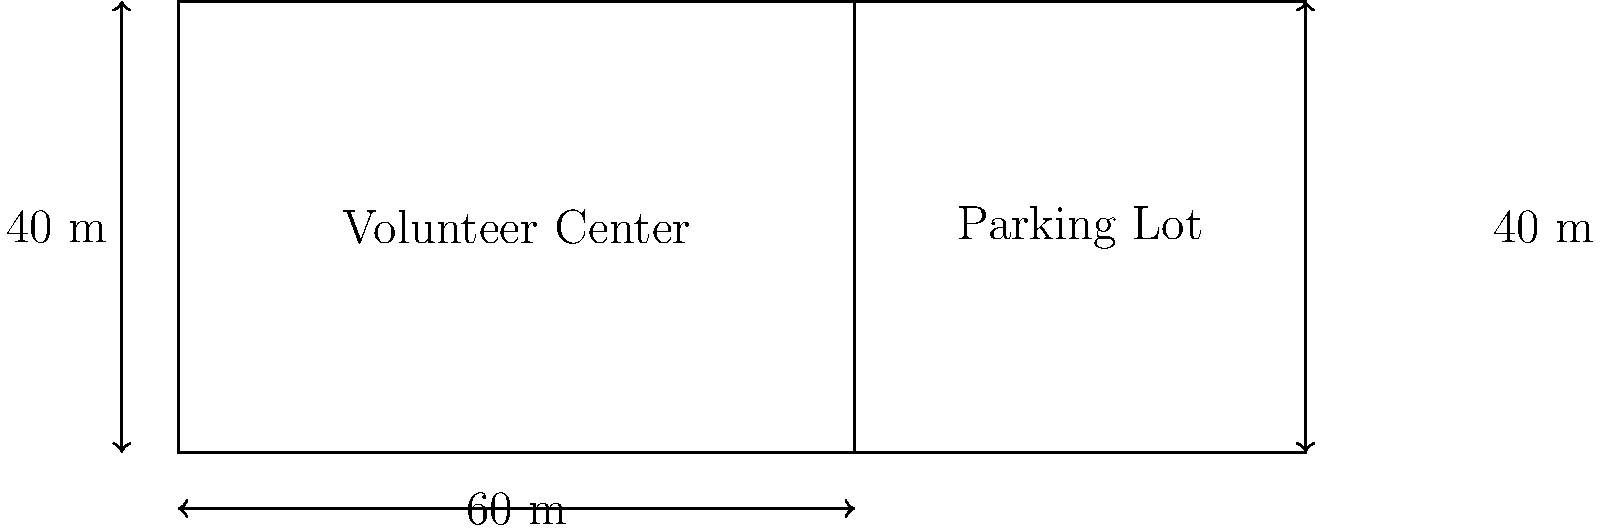A local volunteer center is planning to expand its facilities. The main building is rectangular, measuring 60 meters in length and 40 meters in width. Adjacent to the building is a rectangular parking lot with the same width as the building and an additional 40 meters in length. What is the total area of the volunteer center and its parking lot combined? To solve this problem, we need to follow these steps:

1. Calculate the area of the volunteer center building:
   * Area of rectangle = length × width
   * Area of building = $60 \text{ m} \times 40 \text{ m} = 2400 \text{ m}^2$

2. Calculate the area of the parking lot:
   * The parking lot has the same width as the building (40 m) and an additional 40 m in length
   * Area of parking lot = $40 \text{ m} \times 40 \text{ m} = 1600 \text{ m}^2$

3. Sum up the areas to get the total area:
   * Total area = Area of building + Area of parking lot
   * Total area = $2400 \text{ m}^2 + 1600 \text{ m}^2 = 4000 \text{ m}^2$

Therefore, the total area of the volunteer center and its parking lot combined is $4000 \text{ m}^2$.
Answer: $4000 \text{ m}^2$ 